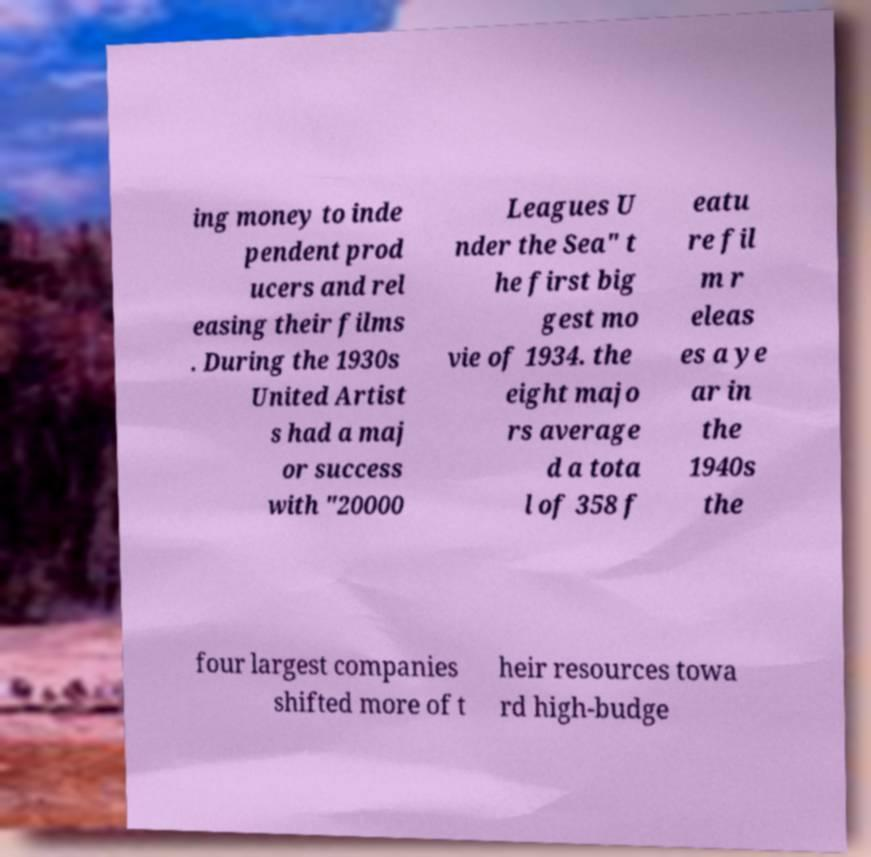There's text embedded in this image that I need extracted. Can you transcribe it verbatim? ing money to inde pendent prod ucers and rel easing their films . During the 1930s United Artist s had a maj or success with "20000 Leagues U nder the Sea" t he first big gest mo vie of 1934. the eight majo rs average d a tota l of 358 f eatu re fil m r eleas es a ye ar in the 1940s the four largest companies shifted more of t heir resources towa rd high-budge 